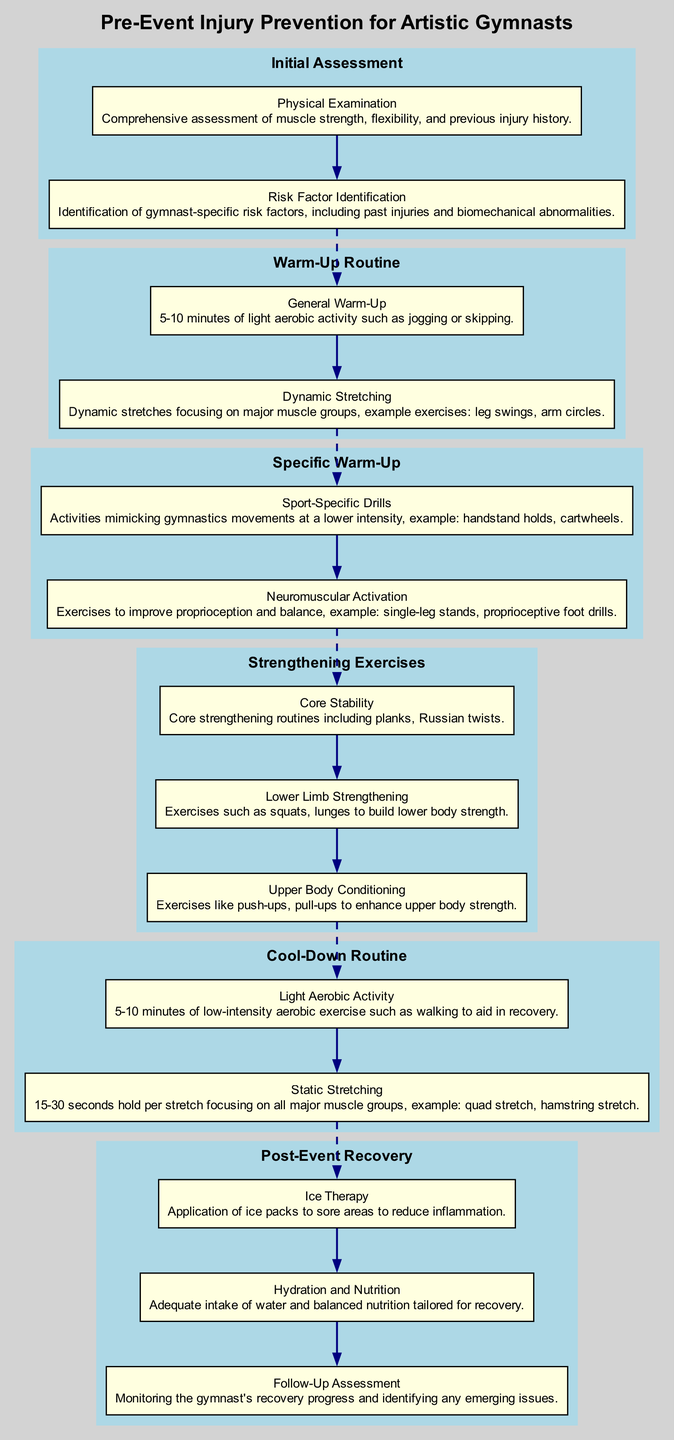What is the first stage in the clinical pathway? According to the diagram, the first stage listed is "Initial Assessment." This is directly visible at the top of the diagram as the starting point of the clinical pathway.
Answer: Initial Assessment How many activities are included in the "Strengthening Exercises" stage? In the "Strengthening Exercises" stage, there are three activities listed: Core Stability, Lower Limb Strengthening, and Upper Body Conditioning. Therefore, the total number of activities is three.
Answer: 3 What type of warm-up is suggested immediately after the General Warm-Up? The activity that follows the "General Warm-Up" is "Dynamic Stretching," as shown in the diagram where the activities are outlined sequentially, highlighting the order of the warm-up routine.
Answer: Dynamic Stretching What is the last activity mentioned in the "Post-Event Recovery" section? The last activity listed in the "Post-Event Recovery" section is "Follow-Up Assessment," which is the concluding item in that stage of the diagram, indicating a check on recovery progress.
Answer: Follow-Up Assessment Which exercise is associated with neuromuscular activation? The exercise related to neuromuscular activation is "Proprioceptive foot drills," as indicated under the "Specific Warm-Up" stage of the diagram, making it clear which exercise corresponds to that focus.
Answer: Proprioceptive foot drills What connects the "Specific Warm-Up" stage to the "Strengthening Exercises" stage? The "Specific Warm-Up" stage connects to the "Strengthening Exercises" stage through a dashed edge in the diagram, which typically signifies a transition between closely related phases of the pathway.
Answer: Dashed edge How many stages are there in total in the clinical pathway? The clinical pathway is comprised of six distinct stages: Initial Assessment, Warm-Up Routine, Specific Warm-Up, Strengthening Exercises, Cool-Down Routine, and Post-Event Recovery. This total can be confirmed by counting each stage listed in the diagram.
Answer: 6 What kind of activities does the "Cool-Down Routine" include? The "Cool-Down Routine" includes two activities: "Light Aerobic Activity" and "Static Stretching." These activities are the sole focus of that specific stage, emphasizing their importance in the recovery process after an event.
Answer: Light Aerobic Activity, Static Stretching Which stage focuses on muscle strength assessment? The "Initial Assessment" stage includes a "Physical Examination" activity, which specifically addresses muscle strength along with flexibility and injury history, showing it's the stage meant for such assessments.
Answer: Initial Assessment 